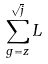<formula> <loc_0><loc_0><loc_500><loc_500>\sum _ { g = z } ^ { \sqrt { j } } { L }</formula> 